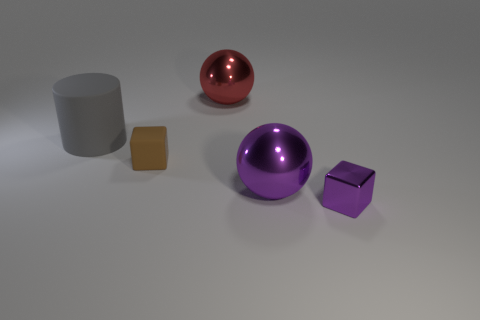Add 3 brown metallic spheres. How many objects exist? 8 Subtract all purple cubes. How many cubes are left? 1 Subtract all spheres. How many objects are left? 3 Subtract 0 gray balls. How many objects are left? 5 Subtract all green blocks. Subtract all brown cylinders. How many blocks are left? 2 Subtract all tiny purple metal cubes. Subtract all purple shiny spheres. How many objects are left? 3 Add 3 small purple cubes. How many small purple cubes are left? 4 Add 3 cyan rubber cylinders. How many cyan rubber cylinders exist? 3 